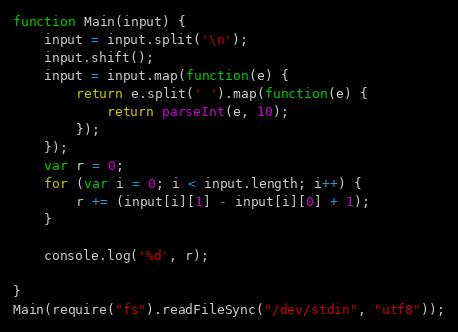<code> <loc_0><loc_0><loc_500><loc_500><_JavaScript_>function Main(input) {
    input = input.split('\n');
    input.shift();
    input = input.map(function(e) {
        return e.split(' ').map(function(e) {
            return parseInt(e, 10);
        });
    });
    var r = 0;
    for (var i = 0; i < input.length; i++) {
        r += (input[i][1] - input[i][0] + 1);
    }

    console.log('%d', r);

}
Main(require("fs").readFileSync("/dev/stdin", "utf8"));
</code> 